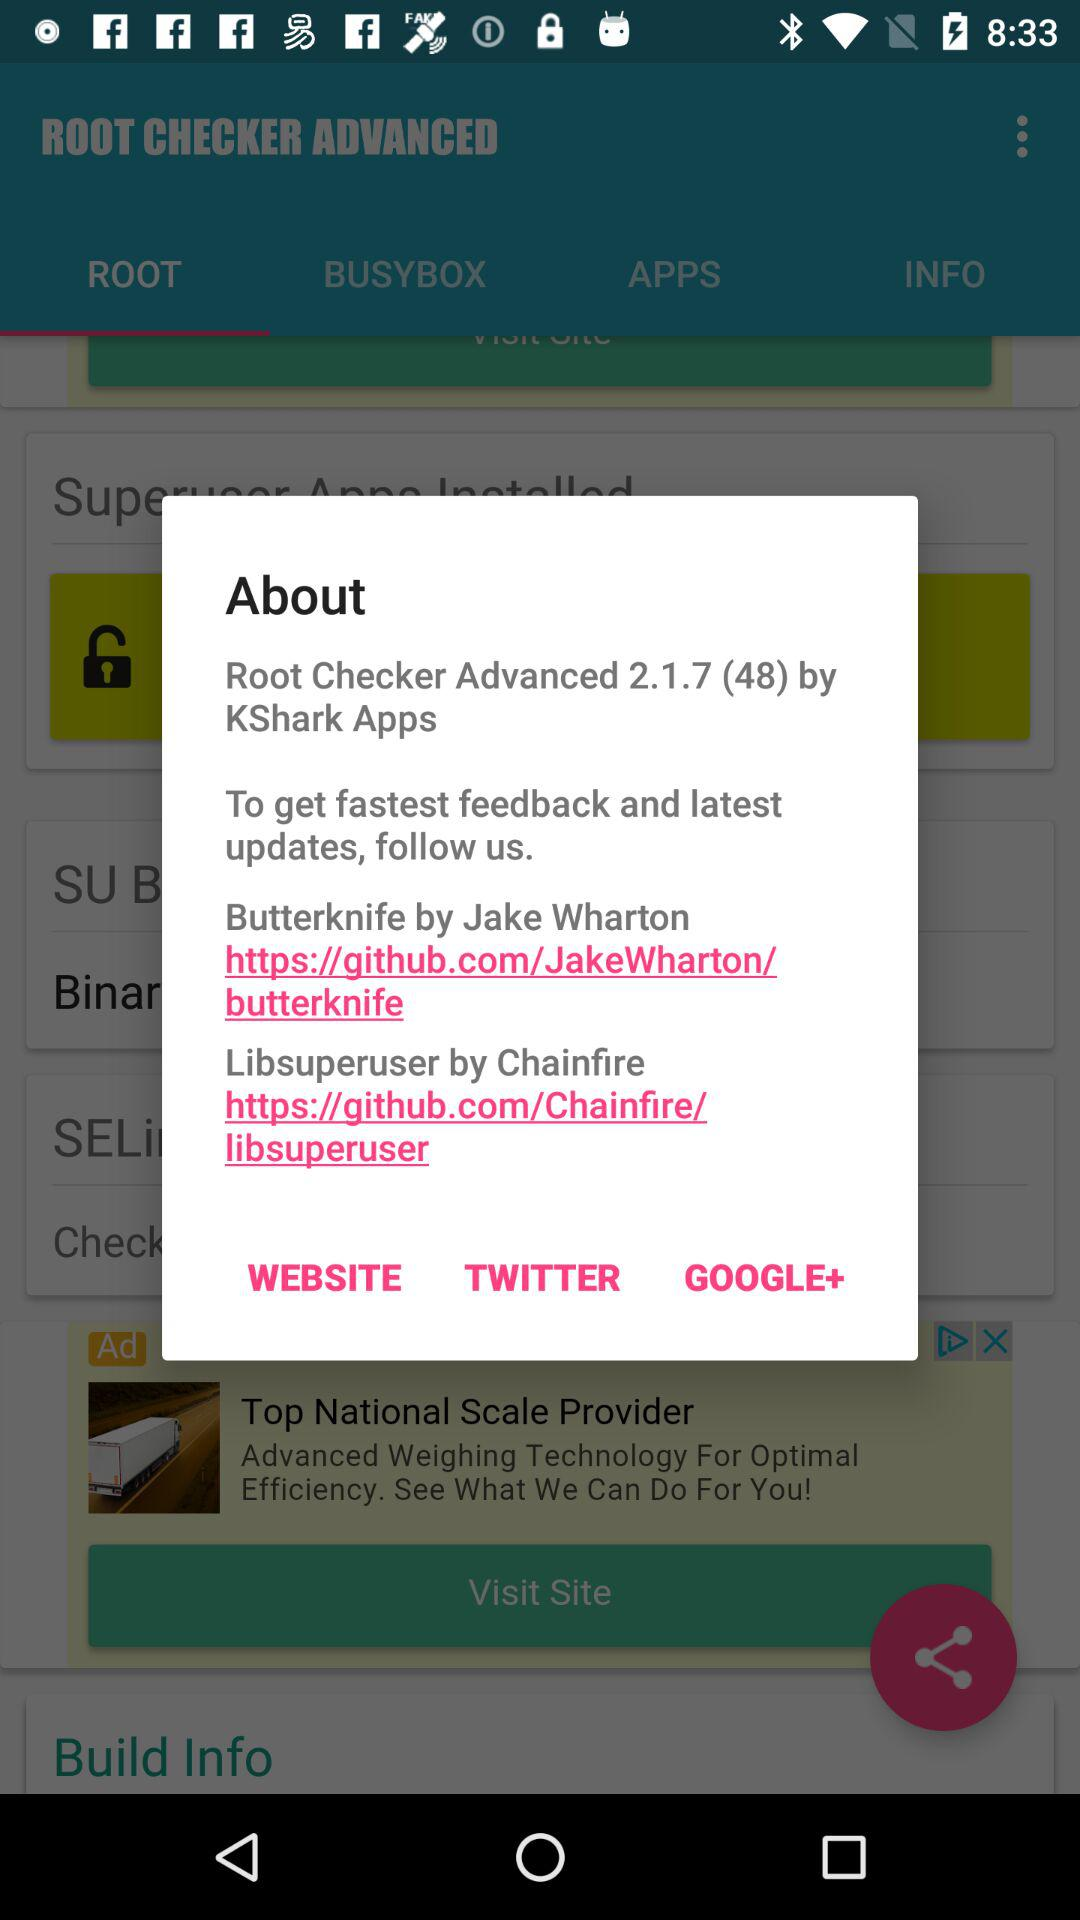What is the version of "Root Checker Advanced"? The version of "Root Checker Advanced" is 2.1.7 (48). 